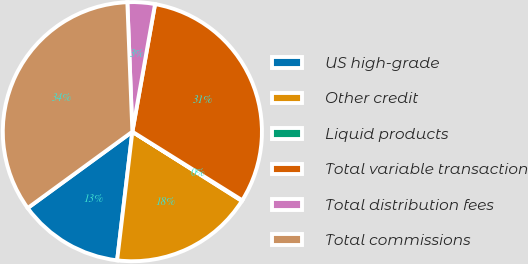Convert chart. <chart><loc_0><loc_0><loc_500><loc_500><pie_chart><fcel>US high-grade<fcel>Other credit<fcel>Liquid products<fcel>Total variable transaction<fcel>Total distribution fees<fcel>Total commissions<nl><fcel>13.09%<fcel>17.9%<fcel>0.09%<fcel>31.08%<fcel>3.42%<fcel>34.41%<nl></chart> 